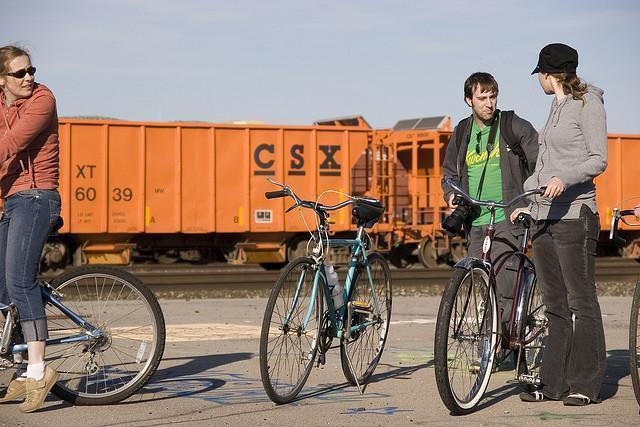How many bikes?
Give a very brief answer. 3. How many people are there?
Give a very brief answer. 3. How many bicycles are there?
Give a very brief answer. 4. 